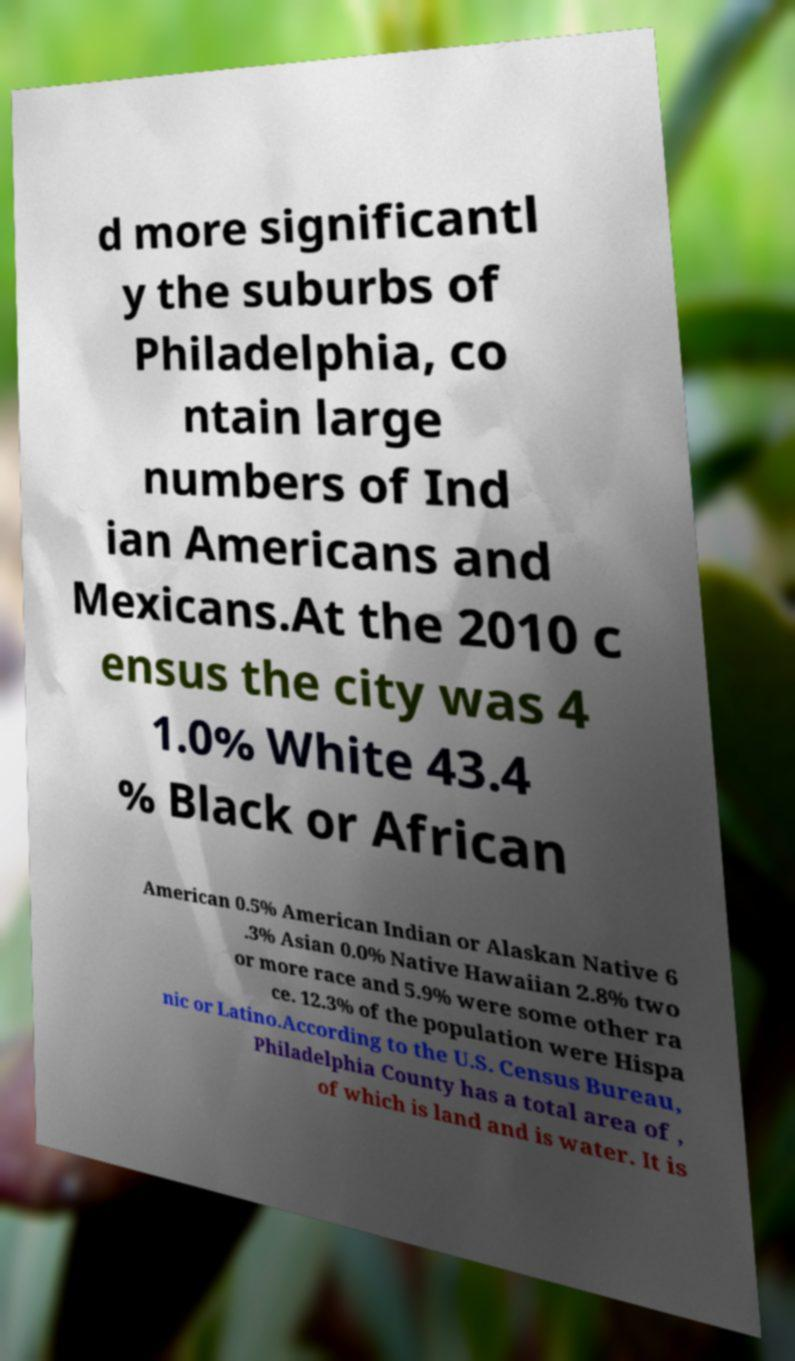Can you read and provide the text displayed in the image?This photo seems to have some interesting text. Can you extract and type it out for me? d more significantl y the suburbs of Philadelphia, co ntain large numbers of Ind ian Americans and Mexicans.At the 2010 c ensus the city was 4 1.0% White 43.4 % Black or African American 0.5% American Indian or Alaskan Native 6 .3% Asian 0.0% Native Hawaiian 2.8% two or more race and 5.9% were some other ra ce. 12.3% of the population were Hispa nic or Latino.According to the U.S. Census Bureau, Philadelphia County has a total area of , of which is land and is water. It is 